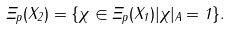Convert formula to latex. <formula><loc_0><loc_0><loc_500><loc_500>\Xi _ { p } ( X _ { 2 } ) = \{ \chi \in \Xi _ { p } ( X _ { 1 } ) | \chi | _ { A } = 1 \} .</formula> 